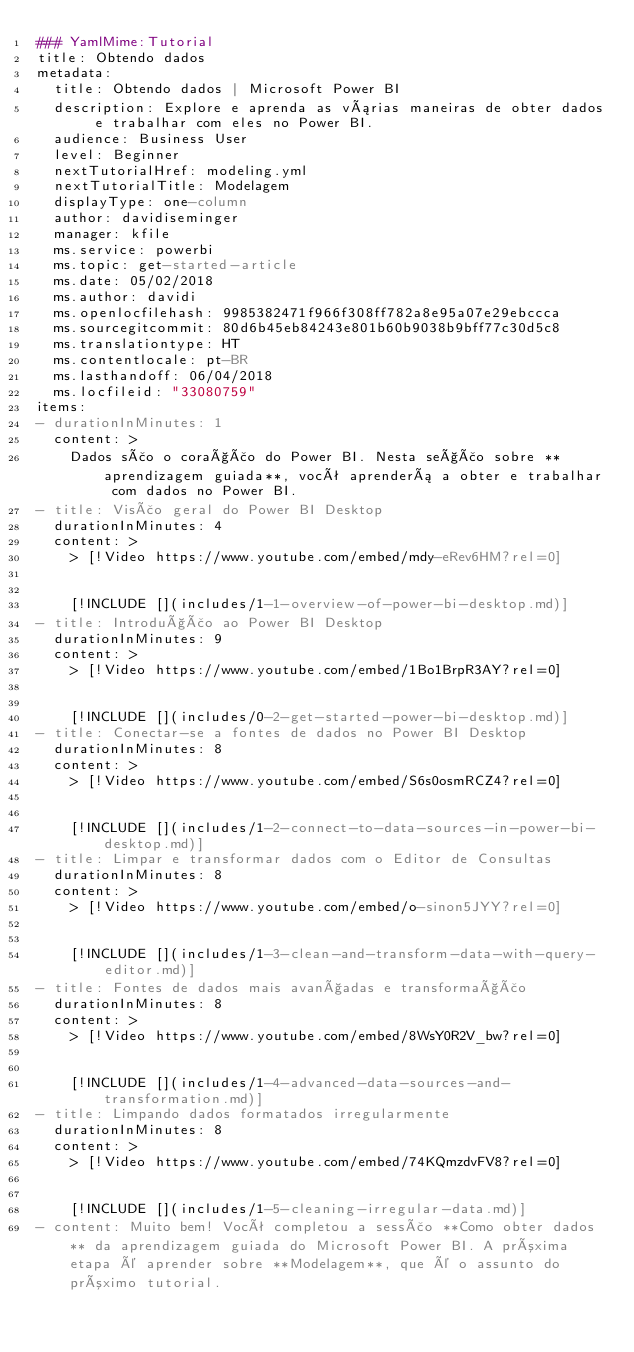Convert code to text. <code><loc_0><loc_0><loc_500><loc_500><_YAML_>### YamlMime:Tutorial
title: Obtendo dados
metadata:
  title: Obtendo dados | Microsoft Power BI
  description: Explore e aprenda as várias maneiras de obter dados e trabalhar com eles no Power BI.
  audience: Business User
  level: Beginner
  nextTutorialHref: modeling.yml
  nextTutorialTitle: Modelagem
  displayType: one-column
  author: davidiseminger
  manager: kfile
  ms.service: powerbi
  ms.topic: get-started-article
  ms.date: 05/02/2018
  ms.author: davidi
  ms.openlocfilehash: 9985382471f966f308ff782a8e95a07e29ebccca
  ms.sourcegitcommit: 80d6b45eb84243e801b60b9038b9bff77c30d5c8
  ms.translationtype: HT
  ms.contentlocale: pt-BR
  ms.lasthandoff: 06/04/2018
  ms.locfileid: "33080759"
items:
- durationInMinutes: 1
  content: >
    Dados são o coração do Power BI. Nesta seção sobre **aprendizagem guiada**, você aprenderá a obter e trabalhar com dados no Power BI.
- title: Visão geral do Power BI Desktop
  durationInMinutes: 4
  content: >
    > [!Video https://www.youtube.com/embed/mdy-eRev6HM?rel=0]


    [!INCLUDE [](includes/1-1-overview-of-power-bi-desktop.md)]
- title: Introdução ao Power BI Desktop
  durationInMinutes: 9
  content: >
    > [!Video https://www.youtube.com/embed/1Bo1BrpR3AY?rel=0]


    [!INCLUDE [](includes/0-2-get-started-power-bi-desktop.md)]
- title: Conectar-se a fontes de dados no Power BI Desktop
  durationInMinutes: 8
  content: >
    > [!Video https://www.youtube.com/embed/S6s0osmRCZ4?rel=0]


    [!INCLUDE [](includes/1-2-connect-to-data-sources-in-power-bi-desktop.md)]
- title: Limpar e transformar dados com o Editor de Consultas
  durationInMinutes: 8
  content: >
    > [!Video https://www.youtube.com/embed/o-sinon5JYY?rel=0]


    [!INCLUDE [](includes/1-3-clean-and-transform-data-with-query-editor.md)]
- title: Fontes de dados mais avançadas e transformação
  durationInMinutes: 8
  content: >
    > [!Video https://www.youtube.com/embed/8WsY0R2V_bw?rel=0]


    [!INCLUDE [](includes/1-4-advanced-data-sources-and-transformation.md)]
- title: Limpando dados formatados irregularmente
  durationInMinutes: 8
  content: >
    > [!Video https://www.youtube.com/embed/74KQmzdvFV8?rel=0]


    [!INCLUDE [](includes/1-5-cleaning-irregular-data.md)]
- content: Muito bem! Você completou a sessão **Como obter dados** da aprendizagem guiada do Microsoft Power BI. A próxima etapa é aprender sobre **Modelagem**, que é o assunto do próximo tutorial.
</code> 